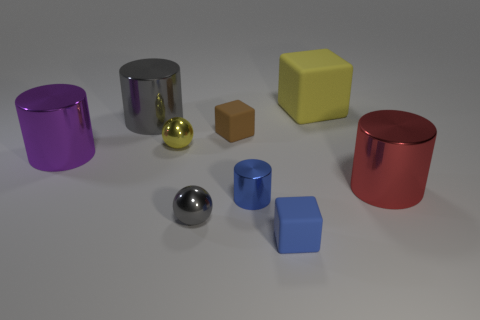What is the shape of the small blue metallic object?
Ensure brevity in your answer.  Cylinder. There is a yellow object right of the block in front of the small matte thing that is left of the blue matte cube; what is its material?
Give a very brief answer. Rubber. Are there more big rubber blocks that are left of the big red shiny thing than small brown cylinders?
Ensure brevity in your answer.  Yes. What material is the other cube that is the same size as the blue rubber cube?
Your answer should be compact. Rubber. Is there a block that has the same size as the yellow shiny sphere?
Provide a short and direct response. Yes. What size is the matte block that is on the left side of the tiny blue cylinder?
Your answer should be compact. Small. How big is the brown block?
Your answer should be very brief. Small. How many balls are brown things or yellow objects?
Provide a short and direct response. 1. What size is the purple object that is the same material as the yellow ball?
Offer a terse response. Large. What number of small cylinders have the same color as the big rubber thing?
Your answer should be very brief. 0. 